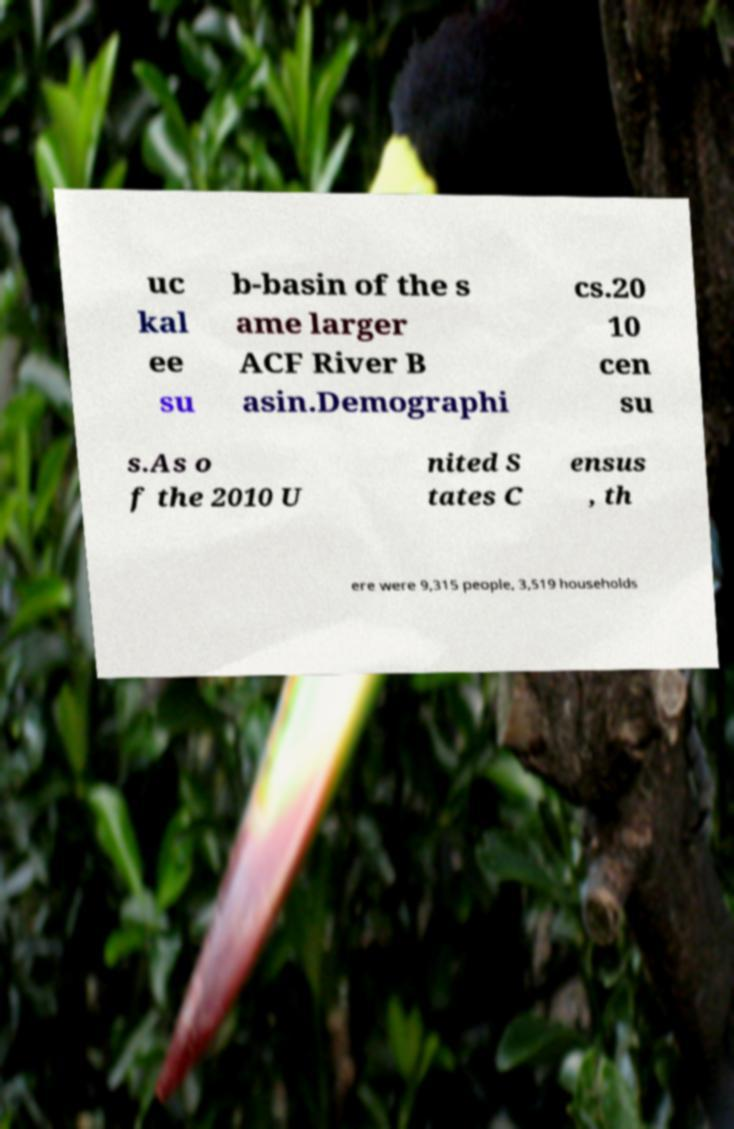There's text embedded in this image that I need extracted. Can you transcribe it verbatim? uc kal ee su b-basin of the s ame larger ACF River B asin.Demographi cs.20 10 cen su s.As o f the 2010 U nited S tates C ensus , th ere were 9,315 people, 3,519 households 